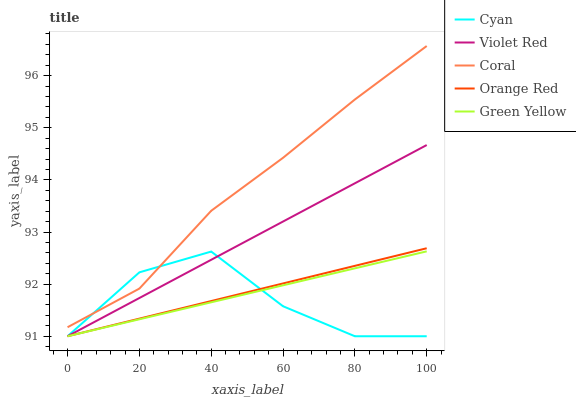Does Cyan have the minimum area under the curve?
Answer yes or no. Yes. Does Coral have the maximum area under the curve?
Answer yes or no. Yes. Does Violet Red have the minimum area under the curve?
Answer yes or no. No. Does Violet Red have the maximum area under the curve?
Answer yes or no. No. Is Orange Red the smoothest?
Answer yes or no. Yes. Is Cyan the roughest?
Answer yes or no. Yes. Is Violet Red the smoothest?
Answer yes or no. No. Is Violet Red the roughest?
Answer yes or no. No. Does Cyan have the lowest value?
Answer yes or no. Yes. Does Coral have the lowest value?
Answer yes or no. No. Does Coral have the highest value?
Answer yes or no. Yes. Does Violet Red have the highest value?
Answer yes or no. No. Is Orange Red less than Coral?
Answer yes or no. Yes. Is Coral greater than Orange Red?
Answer yes or no. Yes. Does Violet Red intersect Orange Red?
Answer yes or no. Yes. Is Violet Red less than Orange Red?
Answer yes or no. No. Is Violet Red greater than Orange Red?
Answer yes or no. No. Does Orange Red intersect Coral?
Answer yes or no. No. 